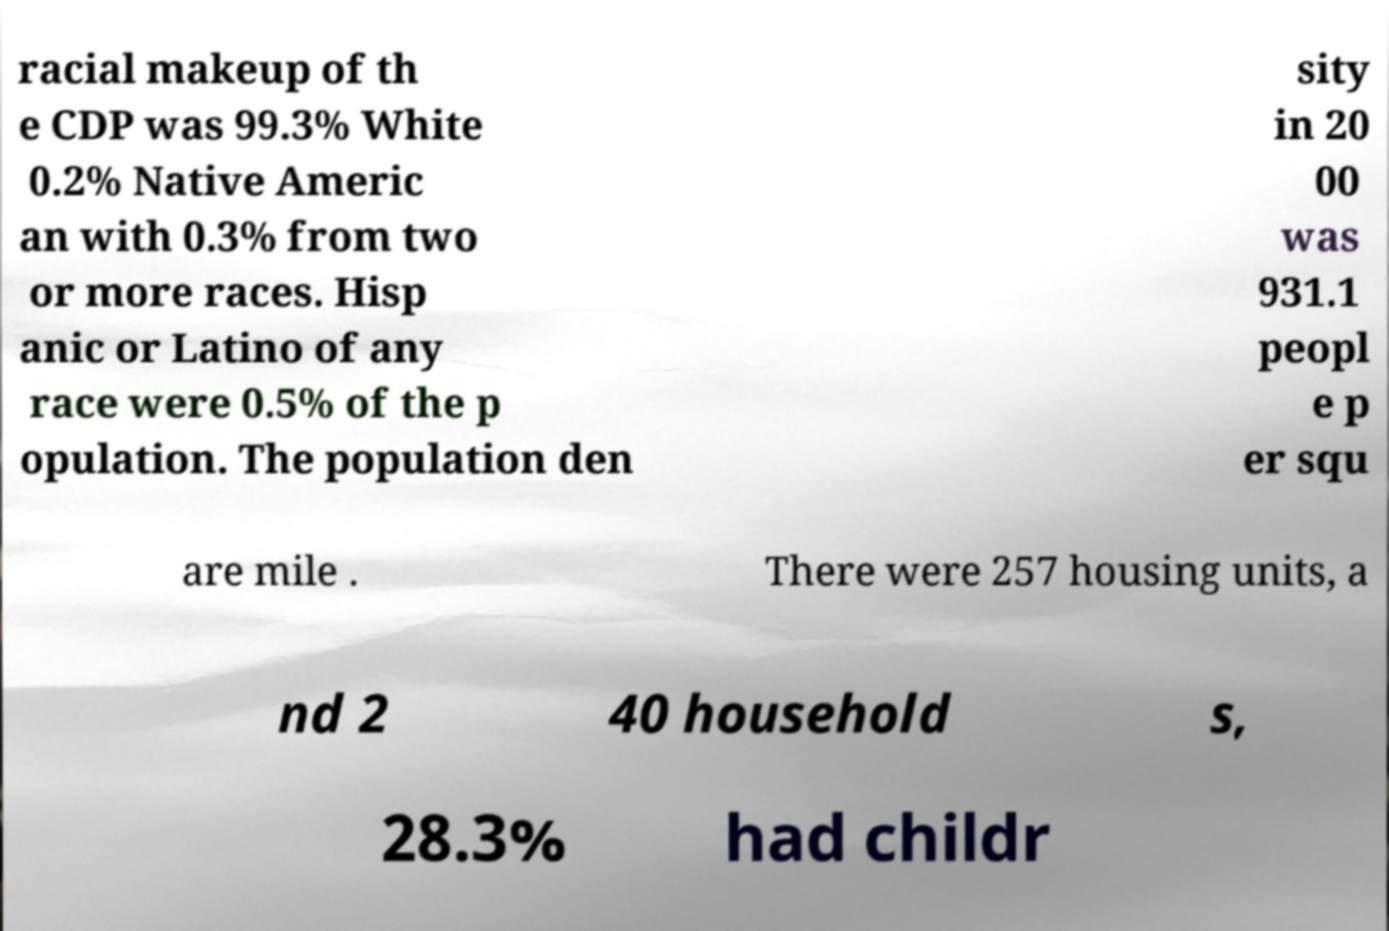There's text embedded in this image that I need extracted. Can you transcribe it verbatim? racial makeup of th e CDP was 99.3% White 0.2% Native Americ an with 0.3% from two or more races. Hisp anic or Latino of any race were 0.5% of the p opulation. The population den sity in 20 00 was 931.1 peopl e p er squ are mile . There were 257 housing units, a nd 2 40 household s, 28.3% had childr 